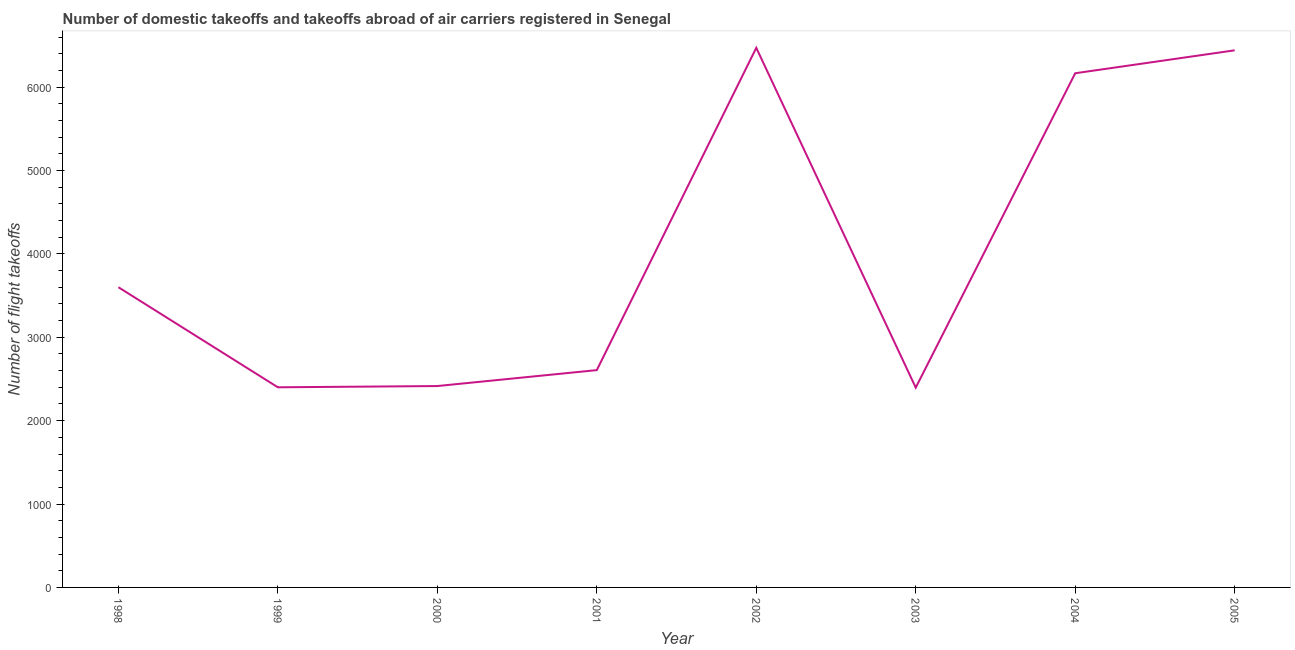What is the number of flight takeoffs in 2003?
Ensure brevity in your answer.  2396. Across all years, what is the maximum number of flight takeoffs?
Offer a terse response. 6471. Across all years, what is the minimum number of flight takeoffs?
Provide a succinct answer. 2396. What is the sum of the number of flight takeoffs?
Provide a short and direct response. 3.25e+04. What is the difference between the number of flight takeoffs in 1998 and 2001?
Your answer should be compact. 994. What is the average number of flight takeoffs per year?
Make the answer very short. 4061.88. What is the median number of flight takeoffs?
Give a very brief answer. 3103. In how many years, is the number of flight takeoffs greater than 800 ?
Your response must be concise. 8. Do a majority of the years between 2001 and 2000 (inclusive) have number of flight takeoffs greater than 3000 ?
Provide a succinct answer. No. What is the ratio of the number of flight takeoffs in 2001 to that in 2002?
Make the answer very short. 0.4. Is the difference between the number of flight takeoffs in 1998 and 1999 greater than the difference between any two years?
Your response must be concise. No. What is the difference between the highest and the lowest number of flight takeoffs?
Provide a succinct answer. 4075. How many years are there in the graph?
Ensure brevity in your answer.  8. What is the difference between two consecutive major ticks on the Y-axis?
Provide a short and direct response. 1000. Does the graph contain any zero values?
Provide a succinct answer. No. Does the graph contain grids?
Your response must be concise. No. What is the title of the graph?
Offer a very short reply. Number of domestic takeoffs and takeoffs abroad of air carriers registered in Senegal. What is the label or title of the Y-axis?
Provide a short and direct response. Number of flight takeoffs. What is the Number of flight takeoffs in 1998?
Offer a very short reply. 3600. What is the Number of flight takeoffs of 1999?
Offer a terse response. 2400. What is the Number of flight takeoffs in 2000?
Ensure brevity in your answer.  2415. What is the Number of flight takeoffs in 2001?
Your answer should be compact. 2606. What is the Number of flight takeoffs in 2002?
Offer a terse response. 6471. What is the Number of flight takeoffs in 2003?
Your response must be concise. 2396. What is the Number of flight takeoffs of 2004?
Give a very brief answer. 6166. What is the Number of flight takeoffs in 2005?
Offer a terse response. 6441. What is the difference between the Number of flight takeoffs in 1998 and 1999?
Give a very brief answer. 1200. What is the difference between the Number of flight takeoffs in 1998 and 2000?
Your answer should be very brief. 1185. What is the difference between the Number of flight takeoffs in 1998 and 2001?
Make the answer very short. 994. What is the difference between the Number of flight takeoffs in 1998 and 2002?
Your response must be concise. -2871. What is the difference between the Number of flight takeoffs in 1998 and 2003?
Offer a very short reply. 1204. What is the difference between the Number of flight takeoffs in 1998 and 2004?
Provide a short and direct response. -2566. What is the difference between the Number of flight takeoffs in 1998 and 2005?
Offer a terse response. -2841. What is the difference between the Number of flight takeoffs in 1999 and 2001?
Provide a short and direct response. -206. What is the difference between the Number of flight takeoffs in 1999 and 2002?
Your response must be concise. -4071. What is the difference between the Number of flight takeoffs in 1999 and 2004?
Provide a succinct answer. -3766. What is the difference between the Number of flight takeoffs in 1999 and 2005?
Provide a succinct answer. -4041. What is the difference between the Number of flight takeoffs in 2000 and 2001?
Make the answer very short. -191. What is the difference between the Number of flight takeoffs in 2000 and 2002?
Ensure brevity in your answer.  -4056. What is the difference between the Number of flight takeoffs in 2000 and 2003?
Offer a very short reply. 19. What is the difference between the Number of flight takeoffs in 2000 and 2004?
Give a very brief answer. -3751. What is the difference between the Number of flight takeoffs in 2000 and 2005?
Ensure brevity in your answer.  -4026. What is the difference between the Number of flight takeoffs in 2001 and 2002?
Your answer should be compact. -3865. What is the difference between the Number of flight takeoffs in 2001 and 2003?
Provide a succinct answer. 210. What is the difference between the Number of flight takeoffs in 2001 and 2004?
Ensure brevity in your answer.  -3560. What is the difference between the Number of flight takeoffs in 2001 and 2005?
Your answer should be compact. -3835. What is the difference between the Number of flight takeoffs in 2002 and 2003?
Ensure brevity in your answer.  4075. What is the difference between the Number of flight takeoffs in 2002 and 2004?
Offer a terse response. 305. What is the difference between the Number of flight takeoffs in 2003 and 2004?
Your response must be concise. -3770. What is the difference between the Number of flight takeoffs in 2003 and 2005?
Offer a terse response. -4045. What is the difference between the Number of flight takeoffs in 2004 and 2005?
Give a very brief answer. -275. What is the ratio of the Number of flight takeoffs in 1998 to that in 1999?
Offer a very short reply. 1.5. What is the ratio of the Number of flight takeoffs in 1998 to that in 2000?
Your answer should be compact. 1.49. What is the ratio of the Number of flight takeoffs in 1998 to that in 2001?
Your answer should be compact. 1.38. What is the ratio of the Number of flight takeoffs in 1998 to that in 2002?
Make the answer very short. 0.56. What is the ratio of the Number of flight takeoffs in 1998 to that in 2003?
Your answer should be compact. 1.5. What is the ratio of the Number of flight takeoffs in 1998 to that in 2004?
Offer a terse response. 0.58. What is the ratio of the Number of flight takeoffs in 1998 to that in 2005?
Keep it short and to the point. 0.56. What is the ratio of the Number of flight takeoffs in 1999 to that in 2000?
Give a very brief answer. 0.99. What is the ratio of the Number of flight takeoffs in 1999 to that in 2001?
Your response must be concise. 0.92. What is the ratio of the Number of flight takeoffs in 1999 to that in 2002?
Give a very brief answer. 0.37. What is the ratio of the Number of flight takeoffs in 1999 to that in 2003?
Provide a succinct answer. 1. What is the ratio of the Number of flight takeoffs in 1999 to that in 2004?
Your answer should be very brief. 0.39. What is the ratio of the Number of flight takeoffs in 1999 to that in 2005?
Provide a short and direct response. 0.37. What is the ratio of the Number of flight takeoffs in 2000 to that in 2001?
Offer a very short reply. 0.93. What is the ratio of the Number of flight takeoffs in 2000 to that in 2002?
Offer a very short reply. 0.37. What is the ratio of the Number of flight takeoffs in 2000 to that in 2003?
Your response must be concise. 1.01. What is the ratio of the Number of flight takeoffs in 2000 to that in 2004?
Keep it short and to the point. 0.39. What is the ratio of the Number of flight takeoffs in 2001 to that in 2002?
Your answer should be very brief. 0.4. What is the ratio of the Number of flight takeoffs in 2001 to that in 2003?
Your response must be concise. 1.09. What is the ratio of the Number of flight takeoffs in 2001 to that in 2004?
Provide a succinct answer. 0.42. What is the ratio of the Number of flight takeoffs in 2001 to that in 2005?
Your answer should be very brief. 0.41. What is the ratio of the Number of flight takeoffs in 2002 to that in 2003?
Give a very brief answer. 2.7. What is the ratio of the Number of flight takeoffs in 2002 to that in 2004?
Your response must be concise. 1.05. What is the ratio of the Number of flight takeoffs in 2003 to that in 2004?
Provide a succinct answer. 0.39. What is the ratio of the Number of flight takeoffs in 2003 to that in 2005?
Ensure brevity in your answer.  0.37. 